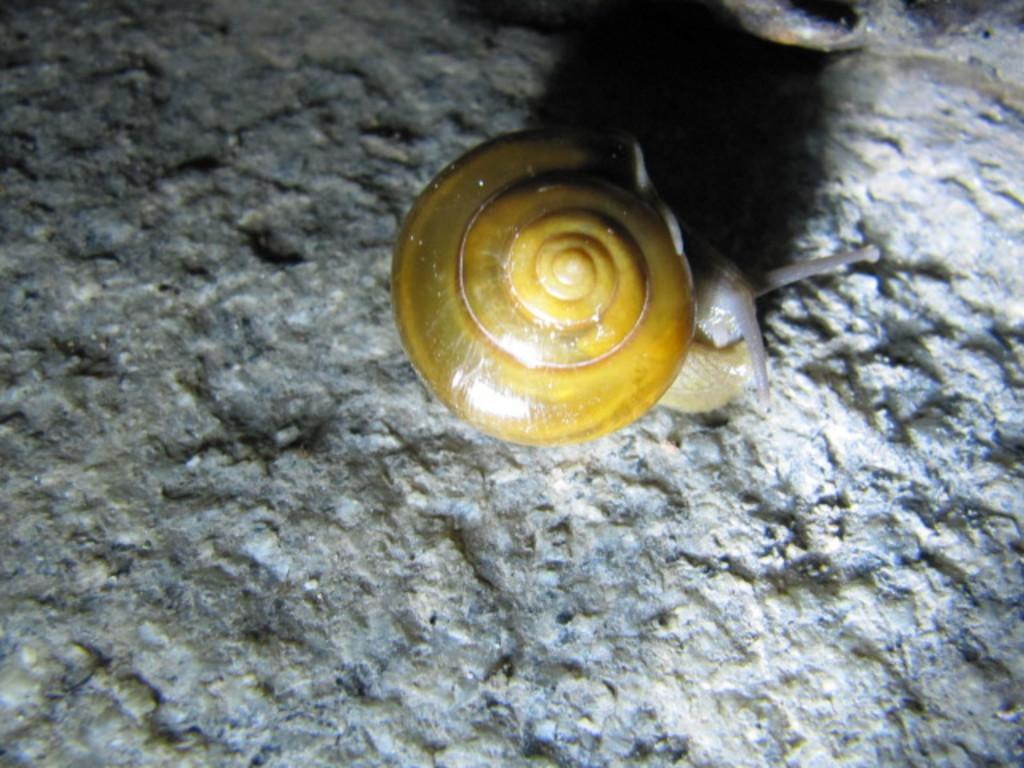Please provide a concise description of this image. In this picture there is a snail coming out of a snail shell and there is an object beside it. 